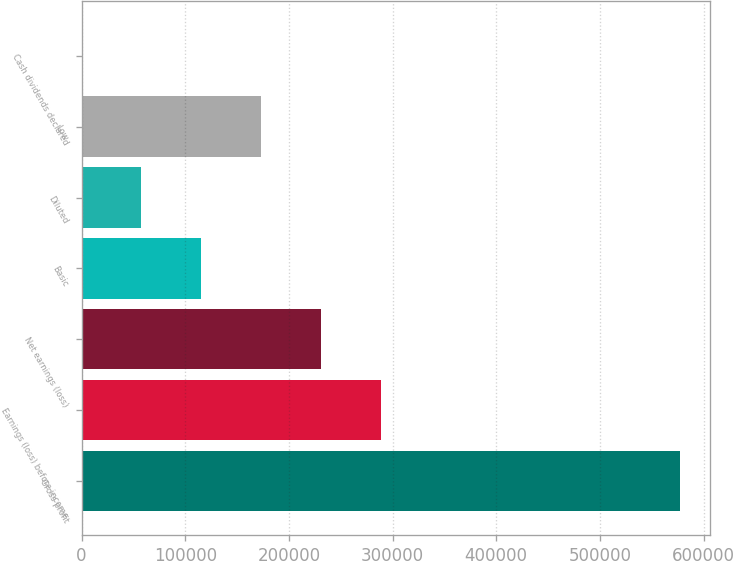Convert chart to OTSL. <chart><loc_0><loc_0><loc_500><loc_500><bar_chart><fcel>Gross profit<fcel>Earnings (loss) before income<fcel>Net earnings (loss)<fcel>Basic<fcel>Diluted<fcel>Low<fcel>Cash dividends declared<nl><fcel>577627<fcel>288814<fcel>231051<fcel>115526<fcel>57762.8<fcel>173288<fcel>0.12<nl></chart> 